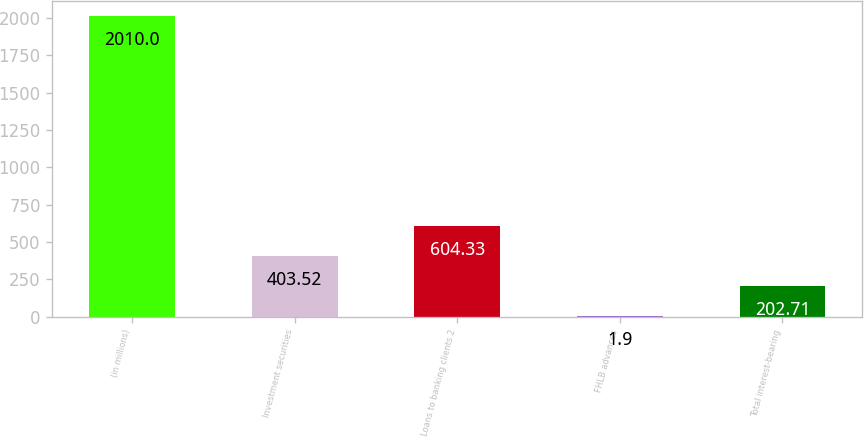Convert chart to OTSL. <chart><loc_0><loc_0><loc_500><loc_500><bar_chart><fcel>(in millions)<fcel>Investment securities<fcel>Loans to banking clients 2<fcel>FHLB advances<fcel>Total interest-bearing<nl><fcel>2010<fcel>403.52<fcel>604.33<fcel>1.9<fcel>202.71<nl></chart> 